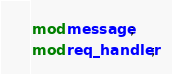<code> <loc_0><loc_0><loc_500><loc_500><_Rust_>mod message;
mod req_handler;

</code> 